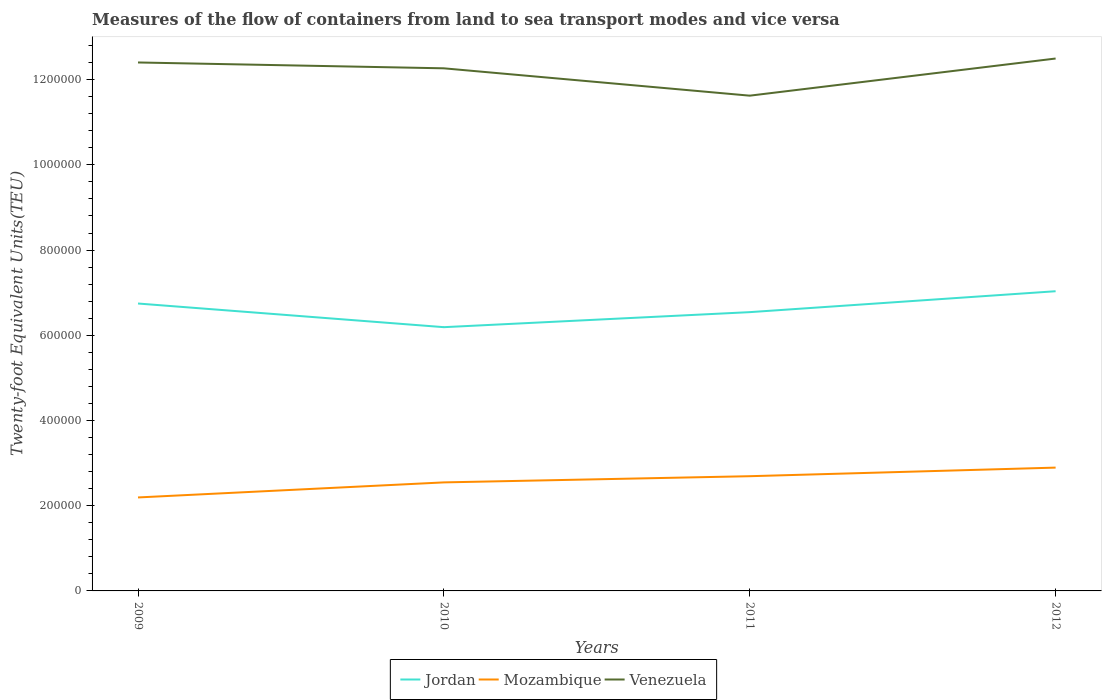How many different coloured lines are there?
Your answer should be very brief. 3. Is the number of lines equal to the number of legend labels?
Offer a very short reply. Yes. Across all years, what is the maximum container port traffic in Jordan?
Offer a terse response. 6.19e+05. In which year was the container port traffic in Mozambique maximum?
Your answer should be compact. 2009. What is the total container port traffic in Mozambique in the graph?
Provide a short and direct response. -3.47e+04. What is the difference between the highest and the second highest container port traffic in Mozambique?
Your answer should be compact. 7.00e+04. What is the difference between two consecutive major ticks on the Y-axis?
Ensure brevity in your answer.  2.00e+05. Does the graph contain any zero values?
Provide a short and direct response. No. How many legend labels are there?
Make the answer very short. 3. What is the title of the graph?
Ensure brevity in your answer.  Measures of the flow of containers from land to sea transport modes and vice versa. What is the label or title of the Y-axis?
Your answer should be compact. Twenty-foot Equivalent Units(TEU). What is the Twenty-foot Equivalent Units(TEU) of Jordan in 2009?
Ensure brevity in your answer.  6.75e+05. What is the Twenty-foot Equivalent Units(TEU) in Mozambique in 2009?
Your answer should be compact. 2.19e+05. What is the Twenty-foot Equivalent Units(TEU) of Venezuela in 2009?
Your response must be concise. 1.24e+06. What is the Twenty-foot Equivalent Units(TEU) of Jordan in 2010?
Ensure brevity in your answer.  6.19e+05. What is the Twenty-foot Equivalent Units(TEU) in Mozambique in 2010?
Your answer should be very brief. 2.55e+05. What is the Twenty-foot Equivalent Units(TEU) in Venezuela in 2010?
Provide a succinct answer. 1.23e+06. What is the Twenty-foot Equivalent Units(TEU) of Jordan in 2011?
Make the answer very short. 6.54e+05. What is the Twenty-foot Equivalent Units(TEU) of Mozambique in 2011?
Offer a very short reply. 2.69e+05. What is the Twenty-foot Equivalent Units(TEU) in Venezuela in 2011?
Your answer should be very brief. 1.16e+06. What is the Twenty-foot Equivalent Units(TEU) in Jordan in 2012?
Keep it short and to the point. 7.03e+05. What is the Twenty-foot Equivalent Units(TEU) in Mozambique in 2012?
Ensure brevity in your answer.  2.89e+05. What is the Twenty-foot Equivalent Units(TEU) of Venezuela in 2012?
Your response must be concise. 1.25e+06. Across all years, what is the maximum Twenty-foot Equivalent Units(TEU) in Jordan?
Offer a very short reply. 7.03e+05. Across all years, what is the maximum Twenty-foot Equivalent Units(TEU) of Mozambique?
Keep it short and to the point. 2.89e+05. Across all years, what is the maximum Twenty-foot Equivalent Units(TEU) in Venezuela?
Your answer should be compact. 1.25e+06. Across all years, what is the minimum Twenty-foot Equivalent Units(TEU) of Jordan?
Give a very brief answer. 6.19e+05. Across all years, what is the minimum Twenty-foot Equivalent Units(TEU) in Mozambique?
Your response must be concise. 2.19e+05. Across all years, what is the minimum Twenty-foot Equivalent Units(TEU) in Venezuela?
Offer a very short reply. 1.16e+06. What is the total Twenty-foot Equivalent Units(TEU) of Jordan in the graph?
Offer a very short reply. 2.65e+06. What is the total Twenty-foot Equivalent Units(TEU) of Mozambique in the graph?
Your response must be concise. 1.03e+06. What is the total Twenty-foot Equivalent Units(TEU) of Venezuela in the graph?
Offer a very short reply. 4.88e+06. What is the difference between the Twenty-foot Equivalent Units(TEU) in Jordan in 2009 and that in 2010?
Provide a short and direct response. 5.55e+04. What is the difference between the Twenty-foot Equivalent Units(TEU) in Mozambique in 2009 and that in 2010?
Provide a short and direct response. -3.53e+04. What is the difference between the Twenty-foot Equivalent Units(TEU) of Venezuela in 2009 and that in 2010?
Offer a very short reply. 1.37e+04. What is the difference between the Twenty-foot Equivalent Units(TEU) in Jordan in 2009 and that in 2011?
Provide a succinct answer. 2.02e+04. What is the difference between the Twenty-foot Equivalent Units(TEU) of Mozambique in 2009 and that in 2011?
Make the answer very short. -4.98e+04. What is the difference between the Twenty-foot Equivalent Units(TEU) of Venezuela in 2009 and that in 2011?
Keep it short and to the point. 7.79e+04. What is the difference between the Twenty-foot Equivalent Units(TEU) in Jordan in 2009 and that in 2012?
Keep it short and to the point. -2.88e+04. What is the difference between the Twenty-foot Equivalent Units(TEU) in Mozambique in 2009 and that in 2012?
Provide a short and direct response. -7.00e+04. What is the difference between the Twenty-foot Equivalent Units(TEU) of Venezuela in 2009 and that in 2012?
Provide a succinct answer. -9248.81. What is the difference between the Twenty-foot Equivalent Units(TEU) of Jordan in 2010 and that in 2011?
Offer a very short reply. -3.53e+04. What is the difference between the Twenty-foot Equivalent Units(TEU) in Mozambique in 2010 and that in 2011?
Your answer should be very brief. -1.45e+04. What is the difference between the Twenty-foot Equivalent Units(TEU) in Venezuela in 2010 and that in 2011?
Offer a terse response. 6.42e+04. What is the difference between the Twenty-foot Equivalent Units(TEU) of Jordan in 2010 and that in 2012?
Keep it short and to the point. -8.44e+04. What is the difference between the Twenty-foot Equivalent Units(TEU) in Mozambique in 2010 and that in 2012?
Keep it short and to the point. -3.47e+04. What is the difference between the Twenty-foot Equivalent Units(TEU) of Venezuela in 2010 and that in 2012?
Offer a terse response. -2.30e+04. What is the difference between the Twenty-foot Equivalent Units(TEU) of Jordan in 2011 and that in 2012?
Offer a very short reply. -4.91e+04. What is the difference between the Twenty-foot Equivalent Units(TEU) of Mozambique in 2011 and that in 2012?
Offer a very short reply. -2.02e+04. What is the difference between the Twenty-foot Equivalent Units(TEU) in Venezuela in 2011 and that in 2012?
Offer a very short reply. -8.72e+04. What is the difference between the Twenty-foot Equivalent Units(TEU) in Jordan in 2009 and the Twenty-foot Equivalent Units(TEU) in Mozambique in 2010?
Provide a short and direct response. 4.20e+05. What is the difference between the Twenty-foot Equivalent Units(TEU) in Jordan in 2009 and the Twenty-foot Equivalent Units(TEU) in Venezuela in 2010?
Provide a succinct answer. -5.52e+05. What is the difference between the Twenty-foot Equivalent Units(TEU) in Mozambique in 2009 and the Twenty-foot Equivalent Units(TEU) in Venezuela in 2010?
Provide a short and direct response. -1.01e+06. What is the difference between the Twenty-foot Equivalent Units(TEU) in Jordan in 2009 and the Twenty-foot Equivalent Units(TEU) in Mozambique in 2011?
Provide a succinct answer. 4.05e+05. What is the difference between the Twenty-foot Equivalent Units(TEU) in Jordan in 2009 and the Twenty-foot Equivalent Units(TEU) in Venezuela in 2011?
Your response must be concise. -4.88e+05. What is the difference between the Twenty-foot Equivalent Units(TEU) in Mozambique in 2009 and the Twenty-foot Equivalent Units(TEU) in Venezuela in 2011?
Make the answer very short. -9.43e+05. What is the difference between the Twenty-foot Equivalent Units(TEU) in Jordan in 2009 and the Twenty-foot Equivalent Units(TEU) in Mozambique in 2012?
Offer a terse response. 3.85e+05. What is the difference between the Twenty-foot Equivalent Units(TEU) in Jordan in 2009 and the Twenty-foot Equivalent Units(TEU) in Venezuela in 2012?
Your response must be concise. -5.75e+05. What is the difference between the Twenty-foot Equivalent Units(TEU) of Mozambique in 2009 and the Twenty-foot Equivalent Units(TEU) of Venezuela in 2012?
Offer a terse response. -1.03e+06. What is the difference between the Twenty-foot Equivalent Units(TEU) in Jordan in 2010 and the Twenty-foot Equivalent Units(TEU) in Mozambique in 2011?
Keep it short and to the point. 3.50e+05. What is the difference between the Twenty-foot Equivalent Units(TEU) in Jordan in 2010 and the Twenty-foot Equivalent Units(TEU) in Venezuela in 2011?
Ensure brevity in your answer.  -5.43e+05. What is the difference between the Twenty-foot Equivalent Units(TEU) of Mozambique in 2010 and the Twenty-foot Equivalent Units(TEU) of Venezuela in 2011?
Your answer should be very brief. -9.08e+05. What is the difference between the Twenty-foot Equivalent Units(TEU) in Jordan in 2010 and the Twenty-foot Equivalent Units(TEU) in Mozambique in 2012?
Your response must be concise. 3.30e+05. What is the difference between the Twenty-foot Equivalent Units(TEU) in Jordan in 2010 and the Twenty-foot Equivalent Units(TEU) in Venezuela in 2012?
Ensure brevity in your answer.  -6.31e+05. What is the difference between the Twenty-foot Equivalent Units(TEU) in Mozambique in 2010 and the Twenty-foot Equivalent Units(TEU) in Venezuela in 2012?
Provide a short and direct response. -9.95e+05. What is the difference between the Twenty-foot Equivalent Units(TEU) in Jordan in 2011 and the Twenty-foot Equivalent Units(TEU) in Mozambique in 2012?
Provide a short and direct response. 3.65e+05. What is the difference between the Twenty-foot Equivalent Units(TEU) in Jordan in 2011 and the Twenty-foot Equivalent Units(TEU) in Venezuela in 2012?
Give a very brief answer. -5.95e+05. What is the difference between the Twenty-foot Equivalent Units(TEU) of Mozambique in 2011 and the Twenty-foot Equivalent Units(TEU) of Venezuela in 2012?
Keep it short and to the point. -9.80e+05. What is the average Twenty-foot Equivalent Units(TEU) in Jordan per year?
Keep it short and to the point. 6.63e+05. What is the average Twenty-foot Equivalent Units(TEU) in Mozambique per year?
Ensure brevity in your answer.  2.58e+05. What is the average Twenty-foot Equivalent Units(TEU) of Venezuela per year?
Provide a short and direct response. 1.22e+06. In the year 2009, what is the difference between the Twenty-foot Equivalent Units(TEU) in Jordan and Twenty-foot Equivalent Units(TEU) in Mozambique?
Keep it short and to the point. 4.55e+05. In the year 2009, what is the difference between the Twenty-foot Equivalent Units(TEU) in Jordan and Twenty-foot Equivalent Units(TEU) in Venezuela?
Offer a very short reply. -5.66e+05. In the year 2009, what is the difference between the Twenty-foot Equivalent Units(TEU) of Mozambique and Twenty-foot Equivalent Units(TEU) of Venezuela?
Your response must be concise. -1.02e+06. In the year 2010, what is the difference between the Twenty-foot Equivalent Units(TEU) of Jordan and Twenty-foot Equivalent Units(TEU) of Mozambique?
Your answer should be compact. 3.64e+05. In the year 2010, what is the difference between the Twenty-foot Equivalent Units(TEU) in Jordan and Twenty-foot Equivalent Units(TEU) in Venezuela?
Give a very brief answer. -6.08e+05. In the year 2010, what is the difference between the Twenty-foot Equivalent Units(TEU) of Mozambique and Twenty-foot Equivalent Units(TEU) of Venezuela?
Ensure brevity in your answer.  -9.72e+05. In the year 2011, what is the difference between the Twenty-foot Equivalent Units(TEU) in Jordan and Twenty-foot Equivalent Units(TEU) in Mozambique?
Keep it short and to the point. 3.85e+05. In the year 2011, what is the difference between the Twenty-foot Equivalent Units(TEU) of Jordan and Twenty-foot Equivalent Units(TEU) of Venezuela?
Make the answer very short. -5.08e+05. In the year 2011, what is the difference between the Twenty-foot Equivalent Units(TEU) in Mozambique and Twenty-foot Equivalent Units(TEU) in Venezuela?
Provide a succinct answer. -8.93e+05. In the year 2012, what is the difference between the Twenty-foot Equivalent Units(TEU) in Jordan and Twenty-foot Equivalent Units(TEU) in Mozambique?
Offer a very short reply. 4.14e+05. In the year 2012, what is the difference between the Twenty-foot Equivalent Units(TEU) in Jordan and Twenty-foot Equivalent Units(TEU) in Venezuela?
Your answer should be compact. -5.46e+05. In the year 2012, what is the difference between the Twenty-foot Equivalent Units(TEU) of Mozambique and Twenty-foot Equivalent Units(TEU) of Venezuela?
Your response must be concise. -9.60e+05. What is the ratio of the Twenty-foot Equivalent Units(TEU) in Jordan in 2009 to that in 2010?
Your answer should be compact. 1.09. What is the ratio of the Twenty-foot Equivalent Units(TEU) of Mozambique in 2009 to that in 2010?
Offer a terse response. 0.86. What is the ratio of the Twenty-foot Equivalent Units(TEU) in Venezuela in 2009 to that in 2010?
Ensure brevity in your answer.  1.01. What is the ratio of the Twenty-foot Equivalent Units(TEU) in Jordan in 2009 to that in 2011?
Offer a very short reply. 1.03. What is the ratio of the Twenty-foot Equivalent Units(TEU) in Mozambique in 2009 to that in 2011?
Give a very brief answer. 0.81. What is the ratio of the Twenty-foot Equivalent Units(TEU) in Venezuela in 2009 to that in 2011?
Ensure brevity in your answer.  1.07. What is the ratio of the Twenty-foot Equivalent Units(TEU) in Mozambique in 2009 to that in 2012?
Provide a succinct answer. 0.76. What is the ratio of the Twenty-foot Equivalent Units(TEU) of Venezuela in 2009 to that in 2012?
Your answer should be compact. 0.99. What is the ratio of the Twenty-foot Equivalent Units(TEU) of Jordan in 2010 to that in 2011?
Provide a short and direct response. 0.95. What is the ratio of the Twenty-foot Equivalent Units(TEU) of Mozambique in 2010 to that in 2011?
Offer a terse response. 0.95. What is the ratio of the Twenty-foot Equivalent Units(TEU) in Venezuela in 2010 to that in 2011?
Your answer should be very brief. 1.06. What is the ratio of the Twenty-foot Equivalent Units(TEU) in Jordan in 2010 to that in 2012?
Offer a very short reply. 0.88. What is the ratio of the Twenty-foot Equivalent Units(TEU) in Mozambique in 2010 to that in 2012?
Your answer should be compact. 0.88. What is the ratio of the Twenty-foot Equivalent Units(TEU) of Venezuela in 2010 to that in 2012?
Offer a very short reply. 0.98. What is the ratio of the Twenty-foot Equivalent Units(TEU) of Jordan in 2011 to that in 2012?
Make the answer very short. 0.93. What is the ratio of the Twenty-foot Equivalent Units(TEU) in Mozambique in 2011 to that in 2012?
Offer a terse response. 0.93. What is the ratio of the Twenty-foot Equivalent Units(TEU) of Venezuela in 2011 to that in 2012?
Keep it short and to the point. 0.93. What is the difference between the highest and the second highest Twenty-foot Equivalent Units(TEU) in Jordan?
Offer a very short reply. 2.88e+04. What is the difference between the highest and the second highest Twenty-foot Equivalent Units(TEU) of Mozambique?
Your answer should be very brief. 2.02e+04. What is the difference between the highest and the second highest Twenty-foot Equivalent Units(TEU) in Venezuela?
Your response must be concise. 9248.81. What is the difference between the highest and the lowest Twenty-foot Equivalent Units(TEU) in Jordan?
Your answer should be compact. 8.44e+04. What is the difference between the highest and the lowest Twenty-foot Equivalent Units(TEU) of Mozambique?
Your answer should be compact. 7.00e+04. What is the difference between the highest and the lowest Twenty-foot Equivalent Units(TEU) of Venezuela?
Your response must be concise. 8.72e+04. 